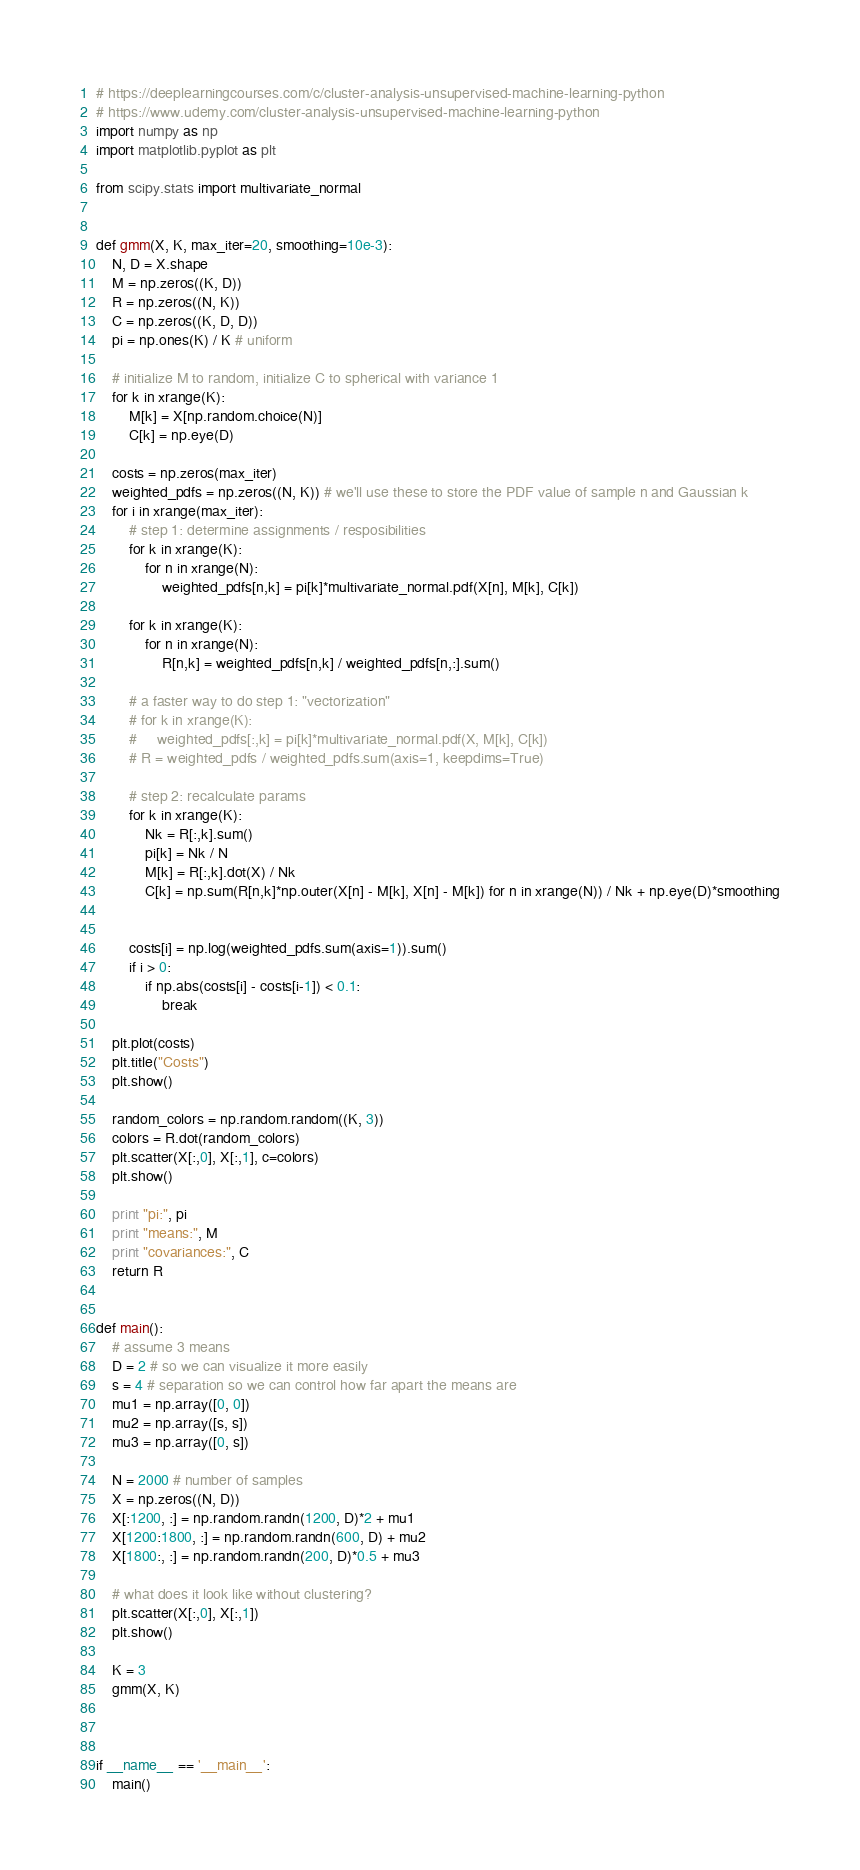<code> <loc_0><loc_0><loc_500><loc_500><_Python_># https://deeplearningcourses.com/c/cluster-analysis-unsupervised-machine-learning-python
# https://www.udemy.com/cluster-analysis-unsupervised-machine-learning-python
import numpy as np
import matplotlib.pyplot as plt

from scipy.stats import multivariate_normal


def gmm(X, K, max_iter=20, smoothing=10e-3):
    N, D = X.shape
    M = np.zeros((K, D))
    R = np.zeros((N, K))
    C = np.zeros((K, D, D))
    pi = np.ones(K) / K # uniform

    # initialize M to random, initialize C to spherical with variance 1
    for k in xrange(K):
        M[k] = X[np.random.choice(N)]
        C[k] = np.eye(D)

    costs = np.zeros(max_iter)
    weighted_pdfs = np.zeros((N, K)) # we'll use these to store the PDF value of sample n and Gaussian k
    for i in xrange(max_iter):
        # step 1: determine assignments / resposibilities
        for k in xrange(K):
            for n in xrange(N):
                weighted_pdfs[n,k] = pi[k]*multivariate_normal.pdf(X[n], M[k], C[k])

        for k in xrange(K):
            for n in xrange(N):
                R[n,k] = weighted_pdfs[n,k] / weighted_pdfs[n,:].sum()

        # a faster way to do step 1: "vectorization"
        # for k in xrange(K):
        #     weighted_pdfs[:,k] = pi[k]*multivariate_normal.pdf(X, M[k], C[k])
        # R = weighted_pdfs / weighted_pdfs.sum(axis=1, keepdims=True)

        # step 2: recalculate params
        for k in xrange(K):
            Nk = R[:,k].sum()
            pi[k] = Nk / N
            M[k] = R[:,k].dot(X) / Nk
            C[k] = np.sum(R[n,k]*np.outer(X[n] - M[k], X[n] - M[k]) for n in xrange(N)) / Nk + np.eye(D)*smoothing


        costs[i] = np.log(weighted_pdfs.sum(axis=1)).sum()
        if i > 0:
            if np.abs(costs[i] - costs[i-1]) < 0.1:
                break

    plt.plot(costs)
    plt.title("Costs")
    plt.show()

    random_colors = np.random.random((K, 3))
    colors = R.dot(random_colors)
    plt.scatter(X[:,0], X[:,1], c=colors)
    plt.show()

    print "pi:", pi
    print "means:", M
    print "covariances:", C
    return R


def main():
    # assume 3 means
    D = 2 # so we can visualize it more easily
    s = 4 # separation so we can control how far apart the means are
    mu1 = np.array([0, 0])
    mu2 = np.array([s, s])
    mu3 = np.array([0, s])

    N = 2000 # number of samples
    X = np.zeros((N, D))
    X[:1200, :] = np.random.randn(1200, D)*2 + mu1
    X[1200:1800, :] = np.random.randn(600, D) + mu2
    X[1800:, :] = np.random.randn(200, D)*0.5 + mu3

    # what does it look like without clustering?
    plt.scatter(X[:,0], X[:,1])
    plt.show()

    K = 3
    gmm(X, K)



if __name__ == '__main__':
    main()
</code> 